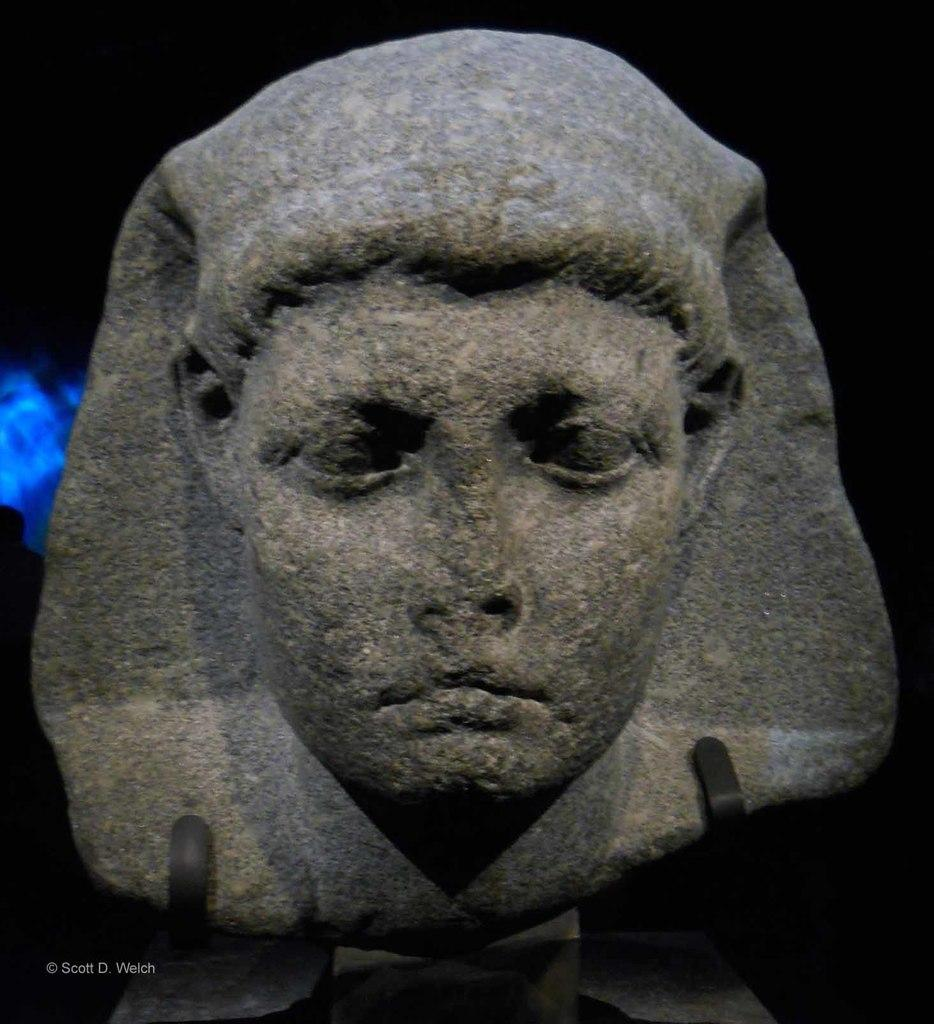What is the main subject of the image? There is a sculpture in the image. What material is the sculpture made of? The sculpture is made up of a rock. What can be seen in the background of the image? The background of the sculpture is dark. What type of chicken can be seen on the sculpture in the image? There is no chicken present on the sculpture in the image; it is made up of a rock. Can you describe the spot on the sculpture where the chicken is sitting? There is no spot or chicken on the sculpture in the image, as it is made up of a rock. 